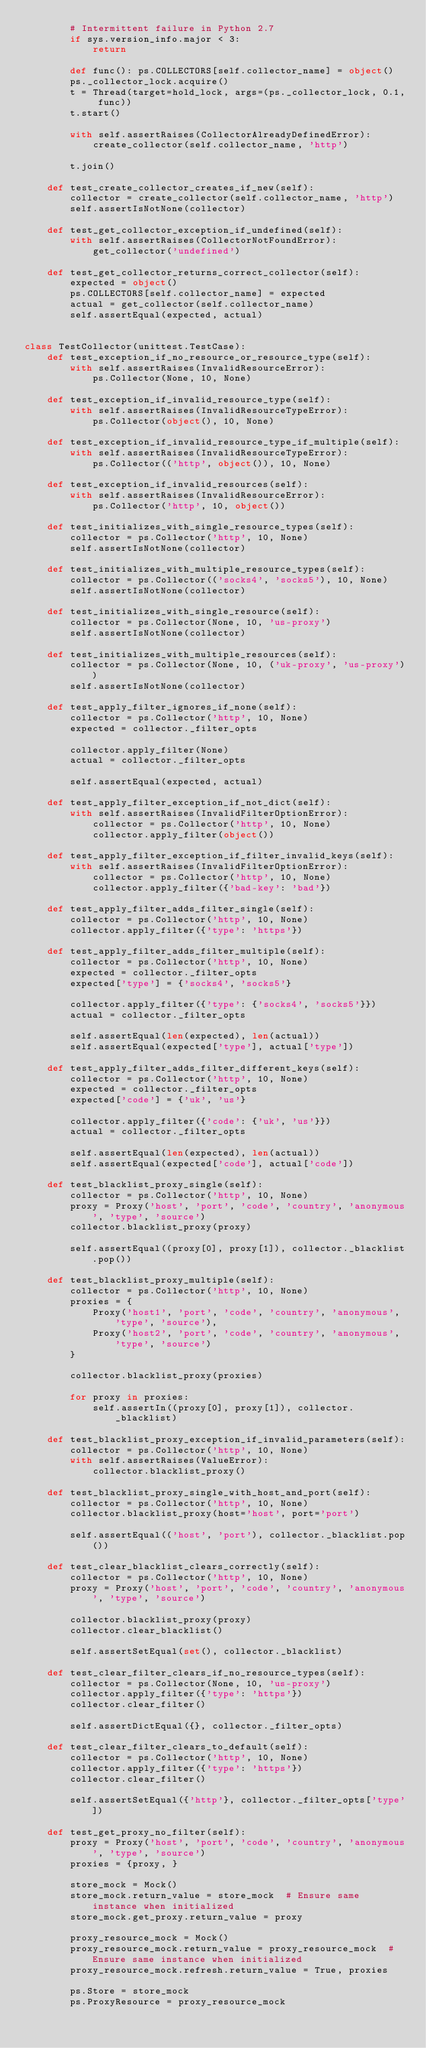Convert code to text. <code><loc_0><loc_0><loc_500><loc_500><_Python_>        # Intermittent failure in Python 2.7
        if sys.version_info.major < 3:
            return

        def func(): ps.COLLECTORS[self.collector_name] = object()
        ps._collector_lock.acquire()
        t = Thread(target=hold_lock, args=(ps._collector_lock, 0.1, func))
        t.start()

        with self.assertRaises(CollectorAlreadyDefinedError):
            create_collector(self.collector_name, 'http')

        t.join()

    def test_create_collector_creates_if_new(self):
        collector = create_collector(self.collector_name, 'http')
        self.assertIsNotNone(collector)

    def test_get_collector_exception_if_undefined(self):
        with self.assertRaises(CollectorNotFoundError):
            get_collector('undefined')

    def test_get_collector_returns_correct_collector(self):
        expected = object()
        ps.COLLECTORS[self.collector_name] = expected
        actual = get_collector(self.collector_name)
        self.assertEqual(expected, actual)


class TestCollector(unittest.TestCase):
    def test_exception_if_no_resource_or_resource_type(self):
        with self.assertRaises(InvalidResourceError):
            ps.Collector(None, 10, None)

    def test_exception_if_invalid_resource_type(self):
        with self.assertRaises(InvalidResourceTypeError):
            ps.Collector(object(), 10, None)

    def test_exception_if_invalid_resource_type_if_multiple(self):
        with self.assertRaises(InvalidResourceTypeError):
            ps.Collector(('http', object()), 10, None)

    def test_exception_if_invalid_resources(self):
        with self.assertRaises(InvalidResourceError):
            ps.Collector('http', 10, object())

    def test_initializes_with_single_resource_types(self):
        collector = ps.Collector('http', 10, None)
        self.assertIsNotNone(collector)

    def test_initializes_with_multiple_resource_types(self):
        collector = ps.Collector(('socks4', 'socks5'), 10, None)
        self.assertIsNotNone(collector)

    def test_initializes_with_single_resource(self):
        collector = ps.Collector(None, 10, 'us-proxy')
        self.assertIsNotNone(collector)

    def test_initializes_with_multiple_resources(self):
        collector = ps.Collector(None, 10, ('uk-proxy', 'us-proxy'))
        self.assertIsNotNone(collector)

    def test_apply_filter_ignores_if_none(self):
        collector = ps.Collector('http', 10, None)
        expected = collector._filter_opts

        collector.apply_filter(None)
        actual = collector._filter_opts

        self.assertEqual(expected, actual)

    def test_apply_filter_exception_if_not_dict(self):
        with self.assertRaises(InvalidFilterOptionError):
            collector = ps.Collector('http', 10, None)
            collector.apply_filter(object())

    def test_apply_filter_exception_if_filter_invalid_keys(self):
        with self.assertRaises(InvalidFilterOptionError):
            collector = ps.Collector('http', 10, None)
            collector.apply_filter({'bad-key': 'bad'})

    def test_apply_filter_adds_filter_single(self):
        collector = ps.Collector('http', 10, None)
        collector.apply_filter({'type': 'https'})

    def test_apply_filter_adds_filter_multiple(self):
        collector = ps.Collector('http', 10, None)
        expected = collector._filter_opts
        expected['type'] = {'socks4', 'socks5'}

        collector.apply_filter({'type': {'socks4', 'socks5'}})
        actual = collector._filter_opts

        self.assertEqual(len(expected), len(actual))
        self.assertEqual(expected['type'], actual['type'])

    def test_apply_filter_adds_filter_different_keys(self):
        collector = ps.Collector('http', 10, None)
        expected = collector._filter_opts
        expected['code'] = {'uk', 'us'}

        collector.apply_filter({'code': {'uk', 'us'}})
        actual = collector._filter_opts

        self.assertEqual(len(expected), len(actual))
        self.assertEqual(expected['code'], actual['code'])

    def test_blacklist_proxy_single(self):
        collector = ps.Collector('http', 10, None)
        proxy = Proxy('host', 'port', 'code', 'country', 'anonymous', 'type', 'source')
        collector.blacklist_proxy(proxy)

        self.assertEqual((proxy[0], proxy[1]), collector._blacklist.pop())

    def test_blacklist_proxy_multiple(self):
        collector = ps.Collector('http', 10, None)
        proxies = {
            Proxy('host1', 'port', 'code', 'country', 'anonymous', 'type', 'source'),
            Proxy('host2', 'port', 'code', 'country', 'anonymous', 'type', 'source')
        }

        collector.blacklist_proxy(proxies)

        for proxy in proxies:
            self.assertIn((proxy[0], proxy[1]), collector._blacklist)

    def test_blacklist_proxy_exception_if_invalid_parameters(self):
        collector = ps.Collector('http', 10, None)
        with self.assertRaises(ValueError):
            collector.blacklist_proxy()

    def test_blacklist_proxy_single_with_host_and_port(self):
        collector = ps.Collector('http', 10, None)
        collector.blacklist_proxy(host='host', port='port')

        self.assertEqual(('host', 'port'), collector._blacklist.pop())

    def test_clear_blacklist_clears_correctly(self):
        collector = ps.Collector('http', 10, None)
        proxy = Proxy('host', 'port', 'code', 'country', 'anonymous', 'type', 'source')

        collector.blacklist_proxy(proxy)
        collector.clear_blacklist()

        self.assertSetEqual(set(), collector._blacklist)

    def test_clear_filter_clears_if_no_resource_types(self):
        collector = ps.Collector(None, 10, 'us-proxy')
        collector.apply_filter({'type': 'https'})
        collector.clear_filter()

        self.assertDictEqual({}, collector._filter_opts)

    def test_clear_filter_clears_to_default(self):
        collector = ps.Collector('http', 10, None)
        collector.apply_filter({'type': 'https'})
        collector.clear_filter()

        self.assertSetEqual({'http'}, collector._filter_opts['type'])

    def test_get_proxy_no_filter(self):
        proxy = Proxy('host', 'port', 'code', 'country', 'anonymous', 'type', 'source')
        proxies = {proxy, }

        store_mock = Mock()
        store_mock.return_value = store_mock  # Ensure same instance when initialized
        store_mock.get_proxy.return_value = proxy

        proxy_resource_mock = Mock()
        proxy_resource_mock.return_value = proxy_resource_mock  # Ensure same instance when initialized
        proxy_resource_mock.refresh.return_value = True, proxies

        ps.Store = store_mock
        ps.ProxyResource = proxy_resource_mock
</code> 